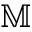<formula> <loc_0><loc_0><loc_500><loc_500>\mathbb { M }</formula> 